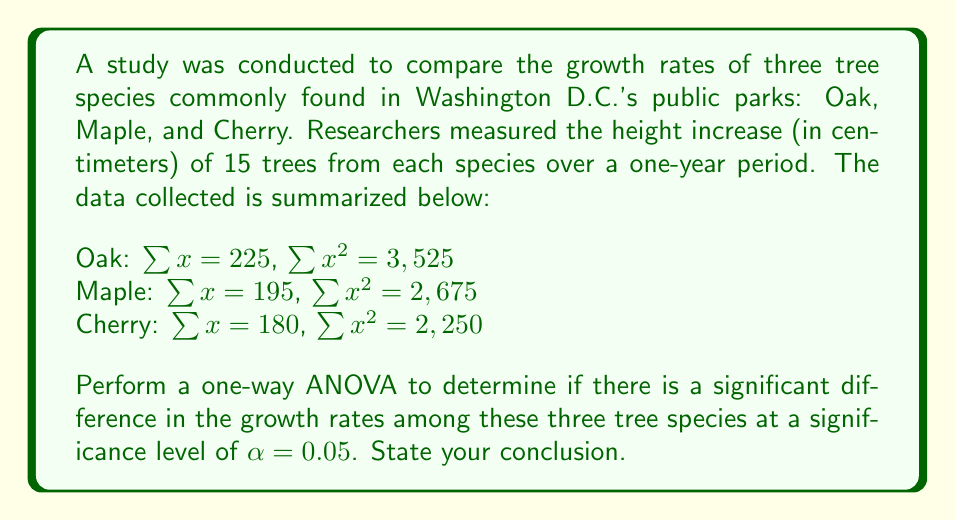Provide a solution to this math problem. To perform a one-way ANOVA, we need to follow these steps:

1. Calculate the sum of squares:

   Total Sum of Squares (SST):
   $$SST = \sum_{i=1}^{k}\sum_{j=1}^{n_i} x_{ij}^2 - \frac{(\sum_{i=1}^{k}\sum_{j=1}^{n_i} x_{ij})^2}{N}$$
   
   $$SST = (3525 + 2675 + 2250) - \frac{(225 + 195 + 180)^2}{45} = 8450 - \frac{600^2}{45} = 8450 - 8000 = 450$$

   Between-group Sum of Squares (SSB):
   $$SSB = \sum_{i=1}^{k} \frac{(\sum_{j=1}^{n_i} x_{ij})^2}{n_i} - \frac{(\sum_{i=1}^{k}\sum_{j=1}^{n_i} x_{ij})^2}{N}$$
   
   $$SSB = \frac{225^2}{15} + \frac{195^2}{15} + \frac{180^2}{15} - \frac{600^2}{45} = 3375 + 2535 + 2160 - 8000 = 70$$

   Within-group Sum of Squares (SSW):
   $$SSW = SST - SSB = 450 - 70 = 380$$

2. Calculate the degrees of freedom:
   $$df_{between} = k - 1 = 3 - 1 = 2$$
   $$df_{within} = N - k = 45 - 3 = 42$$
   $$df_{total} = N - 1 = 45 - 1 = 44$$

3. Calculate the Mean Squares:
   $$MS_{between} = \frac{SSB}{df_{between}} = \frac{70}{2} = 35$$
   $$MS_{within} = \frac{SSW}{df_{within}} = \frac{380}{42} \approx 9.05$$

4. Calculate the F-statistic:
   $$F = \frac{MS_{between}}{MS_{within}} = \frac{35}{9.05} \approx 3.87$$

5. Find the critical F-value:
   For $\alpha = 0.05$, $df_{between} = 2$, and $df_{within} = 42$, the critical F-value is approximately 3.22.

6. Compare the F-statistic to the critical F-value:
   Since $3.87 > 3.22$, we reject the null hypothesis.
Answer: The one-way ANOVA results show a significant difference in growth rates among Oak, Maple, and Cherry trees in Washington D.C.'s public parks (F(2, 42) ≈ 3.87, p < 0.05). This suggests that at least one tree species has a significantly different growth rate compared to the others, which could be important information for urban forestry management and preservation of the city's green spaces. 